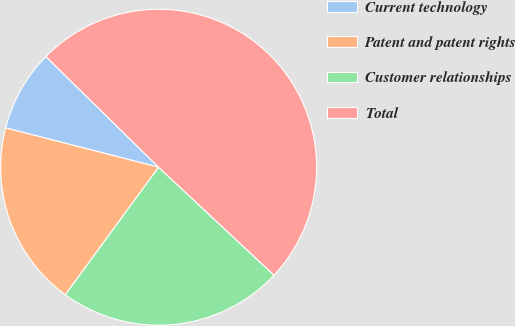Convert chart to OTSL. <chart><loc_0><loc_0><loc_500><loc_500><pie_chart><fcel>Current technology<fcel>Patent and patent rights<fcel>Customer relationships<fcel>Total<nl><fcel>8.35%<fcel>18.95%<fcel>23.08%<fcel>49.62%<nl></chart> 